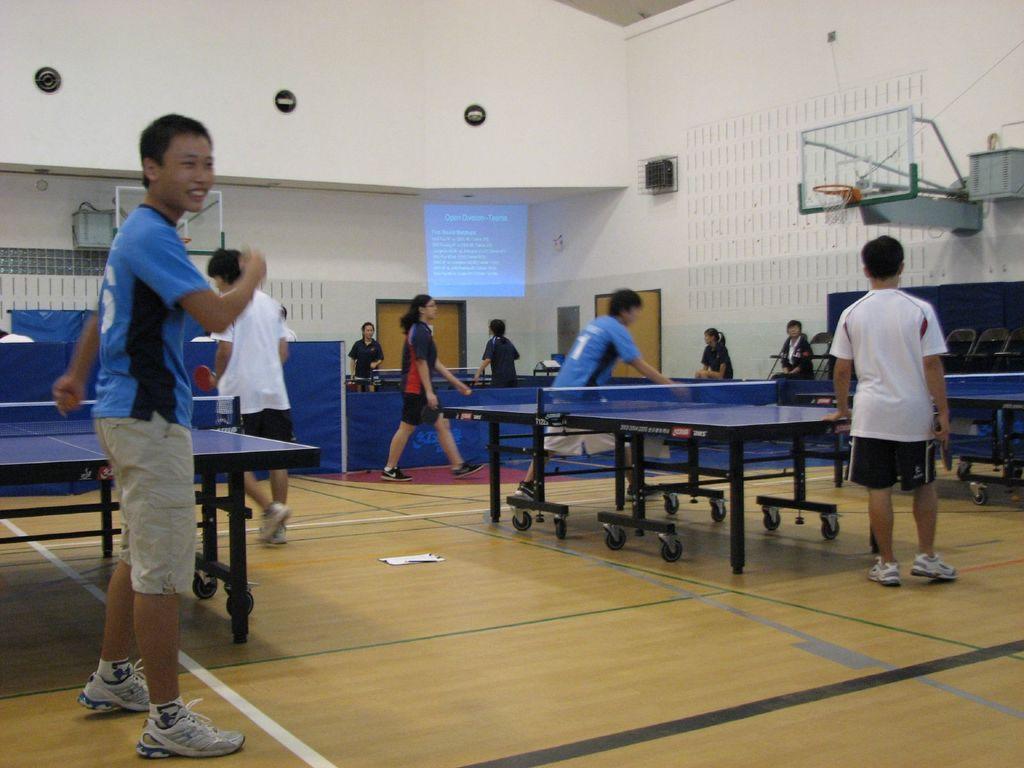Describe this image in one or two sentences. here in this picture we can see the stadium in which they are playing table tennis ,in which there are many people standing near them and playing. 